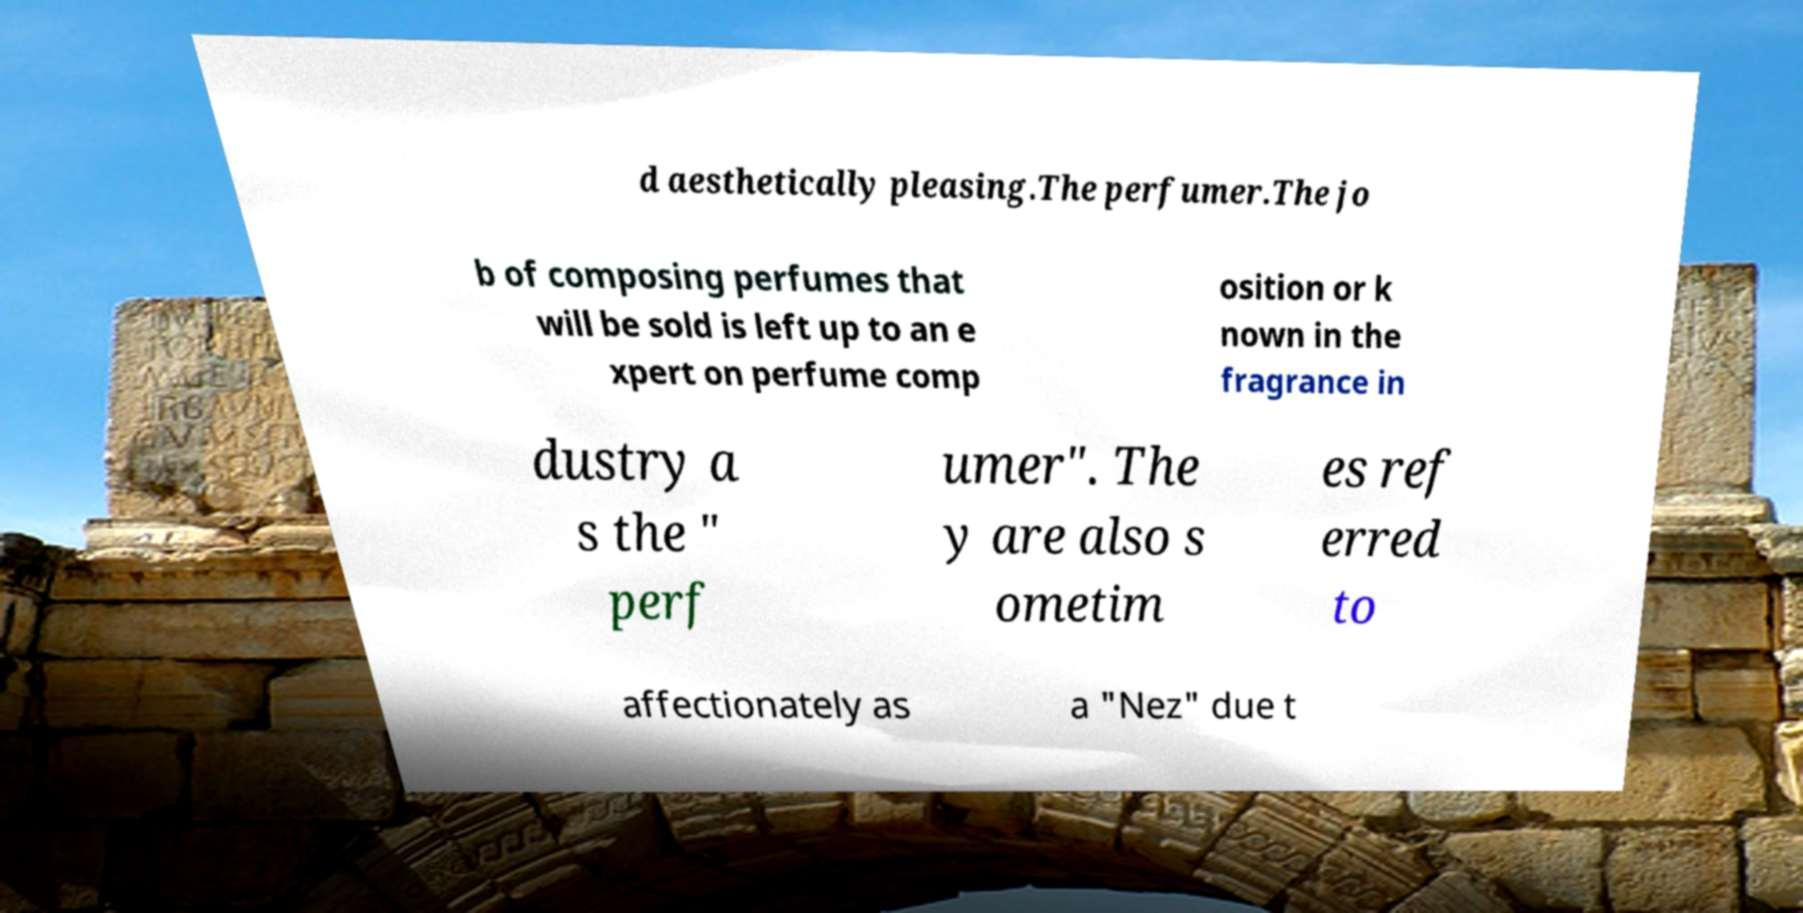Please read and relay the text visible in this image. What does it say? d aesthetically pleasing.The perfumer.The jo b of composing perfumes that will be sold is left up to an e xpert on perfume comp osition or k nown in the fragrance in dustry a s the " perf umer". The y are also s ometim es ref erred to affectionately as a "Nez" due t 